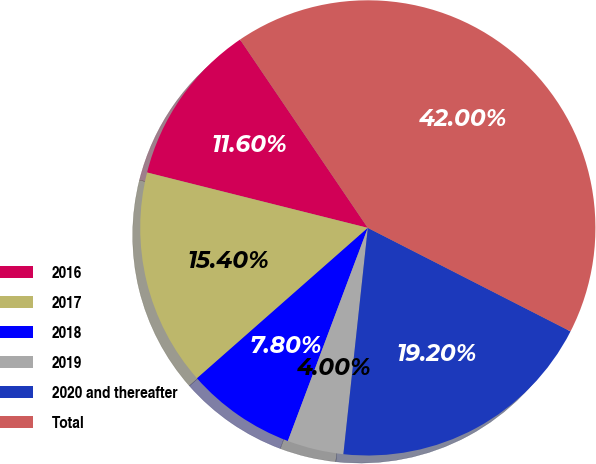Convert chart. <chart><loc_0><loc_0><loc_500><loc_500><pie_chart><fcel>2016<fcel>2017<fcel>2018<fcel>2019<fcel>2020 and thereafter<fcel>Total<nl><fcel>11.6%<fcel>15.4%<fcel>7.8%<fcel>4.0%<fcel>19.2%<fcel>42.0%<nl></chart> 